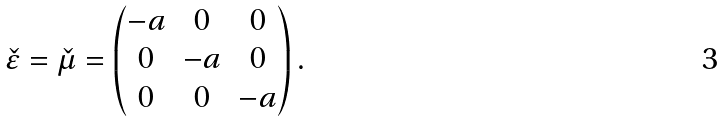Convert formula to latex. <formula><loc_0><loc_0><loc_500><loc_500>\check { \varepsilon } = \check { \mu } = \begin{pmatrix} - a & 0 & 0 \\ 0 & - a & 0 \\ 0 & 0 & - a \end{pmatrix} .</formula> 